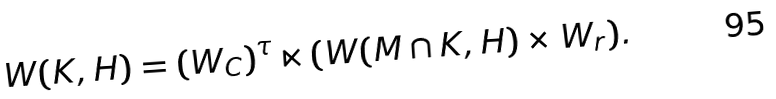Convert formula to latex. <formula><loc_0><loc_0><loc_500><loc_500>W ( K , H ) = ( W _ { C } ) ^ { \tau } \ltimes ( W ( M \cap K , H ) \times W _ { r } ) .</formula> 